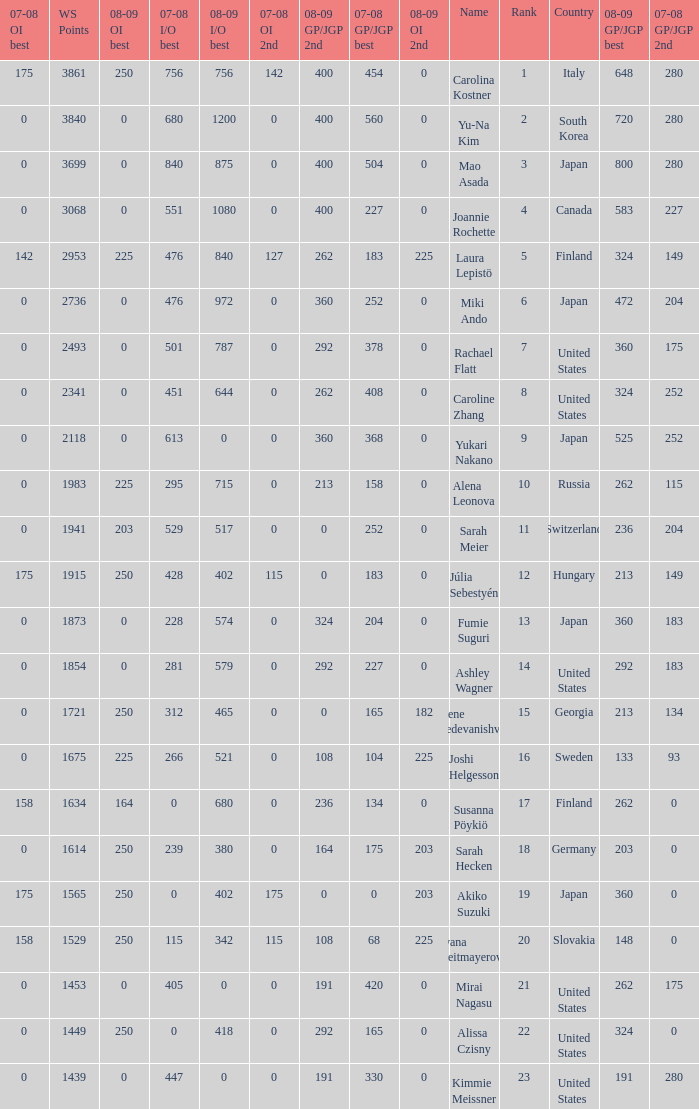08-09 gp/jgp 2nd is 213 and ws points will be what maximum 1983.0. 